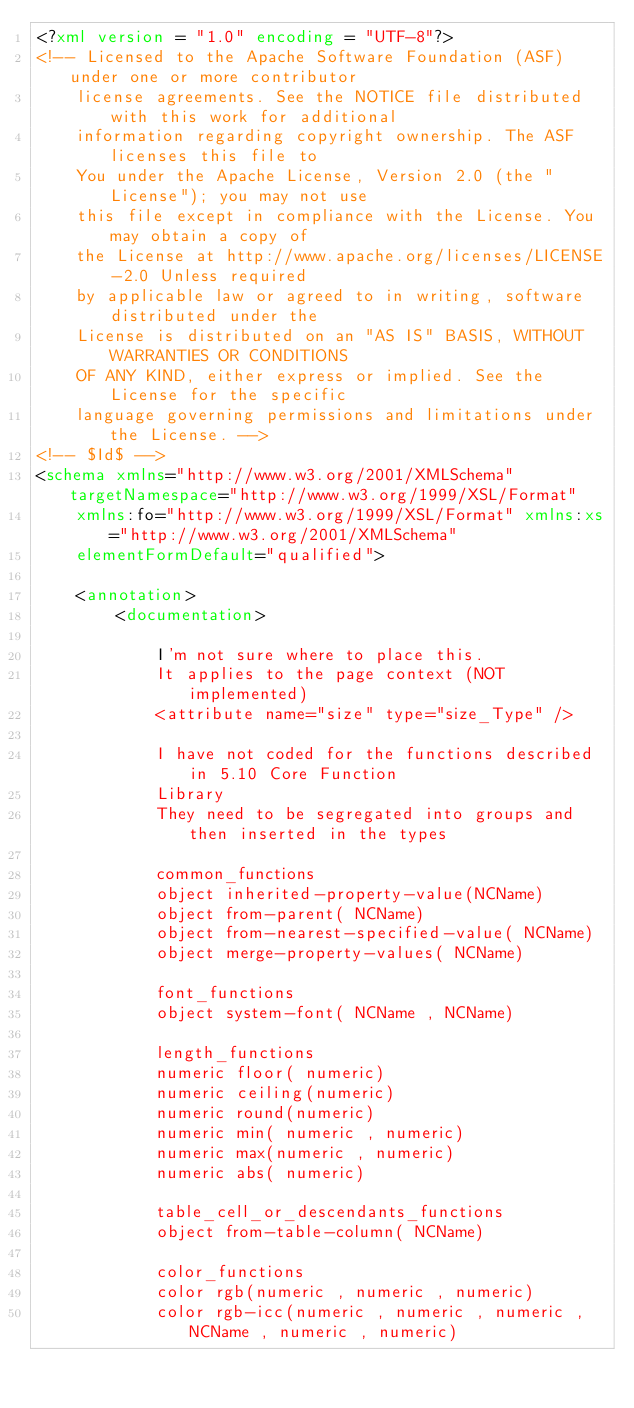Convert code to text. <code><loc_0><loc_0><loc_500><loc_500><_XML_><?xml version = "1.0" encoding = "UTF-8"?>
<!-- Licensed to the Apache Software Foundation (ASF) under one or more contributor 
	license agreements. See the NOTICE file distributed with this work for additional 
	information regarding copyright ownership. The ASF licenses this file to 
	You under the Apache License, Version 2.0 (the "License"); you may not use 
	this file except in compliance with the License. You may obtain a copy of 
	the License at http://www.apache.org/licenses/LICENSE-2.0 Unless required 
	by applicable law or agreed to in writing, software distributed under the 
	License is distributed on an "AS IS" BASIS, WITHOUT WARRANTIES OR CONDITIONS 
	OF ANY KIND, either express or implied. See the License for the specific 
	language governing permissions and limitations under the License. -->
<!-- $Id$ -->
<schema xmlns="http://www.w3.org/2001/XMLSchema" targetNamespace="http://www.w3.org/1999/XSL/Format"
	xmlns:fo="http://www.w3.org/1999/XSL/Format" xmlns:xs="http://www.w3.org/2001/XMLSchema"
	elementFormDefault="qualified">

	<annotation>
		<documentation>

			I'm not sure where to place this.
			It applies to the page context (NOT implemented)
			<attribute name="size" type="size_Type" />

			I have not coded for the functions described in 5.10 Core Function
			Library
			They need to be segregated into groups and then inserted in the types

			common_functions
			object inherited-property-value(NCName)
			object from-parent( NCName)
			object from-nearest-specified-value( NCName)
			object merge-property-values( NCName)

			font_functions
			object system-font( NCName , NCName)

			length_functions
			numeric floor( numeric)
			numeric ceiling(numeric)
			numeric round(numeric)
			numeric min( numeric , numeric)
			numeric max(numeric , numeric)
			numeric abs( numeric)

			table_cell_or_descendants_functions
			object from-table-column( NCName)

			color_functions
			color rgb(numeric , numeric , numeric)
			color rgb-icc(numeric , numeric , numeric , NCName , numeric , numeric)</code> 